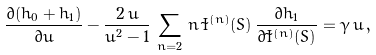Convert formula to latex. <formula><loc_0><loc_0><loc_500><loc_500>\frac { \partial ( h _ { 0 } + h _ { 1 } ) } { \partial u } - \frac { 2 \, u } { u ^ { 2 } - 1 } \, \sum _ { n = 2 } \, n \, \tilde { I } ^ { ( n ) } ( S ) \, \frac { \partial h _ { 1 } } { \partial \tilde { I } ^ { ( n ) } ( S ) } = \gamma \, u \, ,</formula> 